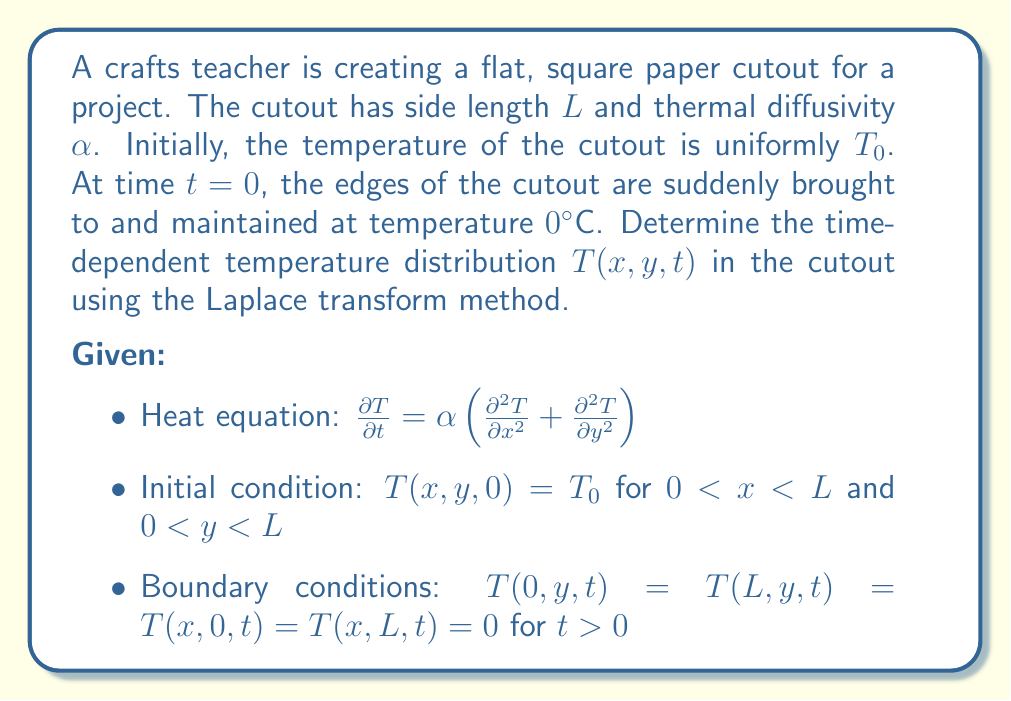Can you answer this question? To solve this problem, we'll use the Laplace transform method:

1) Take the Laplace transform of the heat equation with respect to $t$:
   $$s\bar{T}(x,y,s) - T_0 = \alpha (\frac{\partial^2 \bar{T}}{\partial x^2} + \frac{\partial^2 \bar{T}}{\partial y^2})$$

2) Rearrange the equation:
   $$\frac{\partial^2 \bar{T}}{\partial x^2} + \frac{\partial^2 \bar{T}}{\partial y^2} - \frac{s}{\alpha}\bar{T} = -\frac{T_0}{\alpha}$$

3) Use separation of variables: $\bar{T}(x,y,s) = X(x)Y(y)$
   This leads to two ordinary differential equations:
   $$\frac{d^2X}{dx^2} - \lambda^2X = 0$$
   $$\frac{d^2Y}{dy^2} - \mu^2Y = 0$$
   where $\lambda^2 + \mu^2 = \frac{s}{\alpha}$

4) Solve these equations considering the boundary conditions:
   $$X(x) = A\sin(\frac{n\pi x}{L}), \quad Y(y) = B\sin(\frac{m\pi y}{L})$$
   where $n$ and $m$ are positive integers.

5) The general solution in the Laplace domain is:
   $$\bar{T}(x,y,s) = \sum_{n=1}^{\infty}\sum_{m=1}^{\infty} C_{nm}\sin(\frac{n\pi x}{L})\sin(\frac{m\pi y}{L})$$

6) Find $C_{nm}$ using the initial condition:
   $$C_{nm} = \frac{4T_0}{L^2}\frac{1}{s + \alpha(\frac{n^2\pi^2}{L^2} + \frac{m^2\pi^2}{L^2})}$$

7) The complete solution in the Laplace domain is:
   $$\bar{T}(x,y,s) = \frac{4T_0}{L^2}\sum_{n=1}^{\infty}\sum_{m=1}^{\infty} \frac{\sin(\frac{n\pi x}{L})\sin(\frac{m\pi y}{L})}{s + \alpha(\frac{n^2\pi^2}{L^2} + \frac{m^2\pi^2}{L^2})}$$

8) Take the inverse Laplace transform:
   $$T(x,y,t) = \frac{4T_0}{\pi^2}\sum_{n=1}^{\infty}\sum_{m=1}^{\infty} \frac{\sin(\frac{n\pi x}{L})\sin(\frac{m\pi y}{L})}{nm}e^{-\alpha(\frac{n^2\pi^2}{L^2} + \frac{m^2\pi^2}{L^2})t}$$

This is the time-dependent temperature distribution in the cutout.
Answer: $$T(x,y,t) = \frac{4T_0}{\pi^2}\sum_{n=1}^{\infty}\sum_{m=1}^{\infty} \frac{\sin(\frac{n\pi x}{L})\sin(\frac{m\pi y}{L})}{nm}e^{-\alpha(\frac{n^2\pi^2}{L^2} + \frac{m^2\pi^2}{L^2})t}$$ 